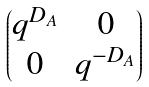<formula> <loc_0><loc_0><loc_500><loc_500>\begin{pmatrix} q ^ { D _ { A } } & 0 \\ 0 & q ^ { - D _ { A } } \end{pmatrix}</formula> 